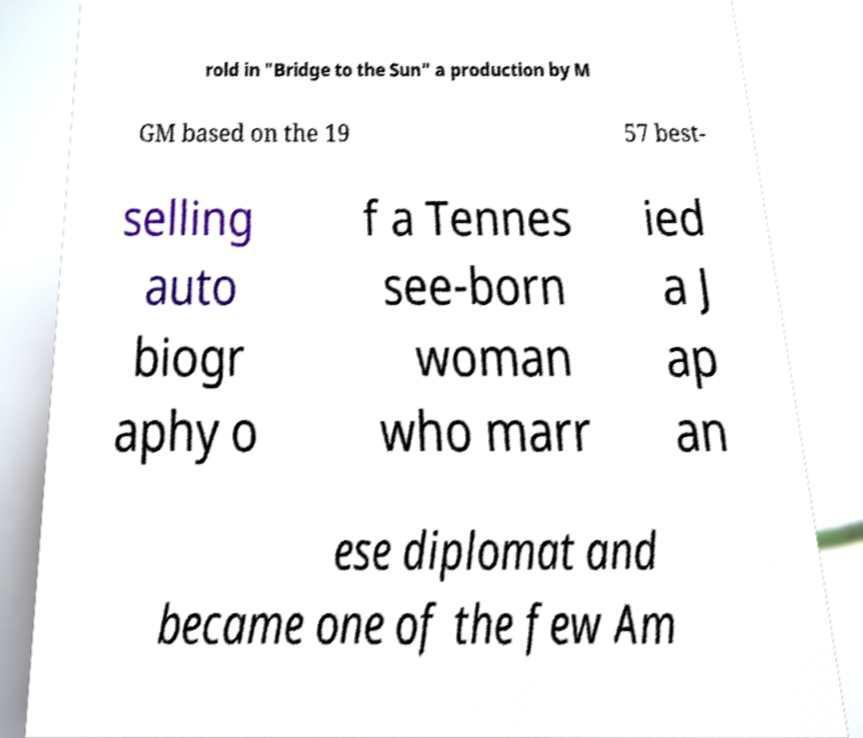For documentation purposes, I need the text within this image transcribed. Could you provide that? rold in "Bridge to the Sun" a production by M GM based on the 19 57 best- selling auto biogr aphy o f a Tennes see-born woman who marr ied a J ap an ese diplomat and became one of the few Am 